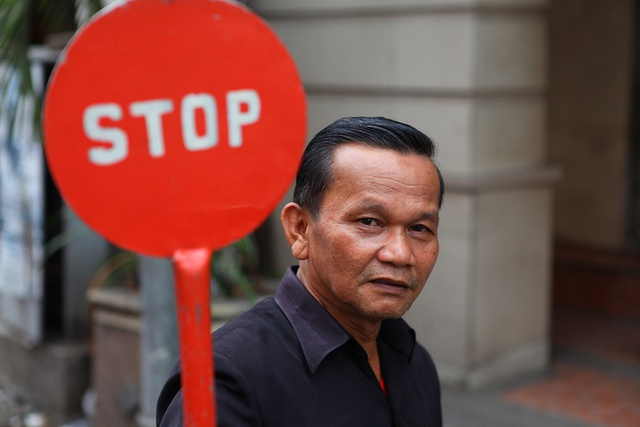Describe the objects in this image and their specific colors. I can see stop sign in darkgreen, red, lightgray, salmon, and lightpink tones and people in darkgreen, black, brown, maroon, and lightpink tones in this image. 